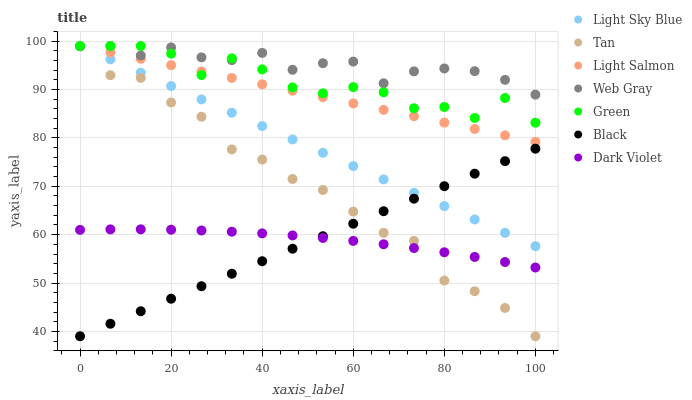Does Black have the minimum area under the curve?
Answer yes or no. Yes. Does Web Gray have the maximum area under the curve?
Answer yes or no. Yes. Does Dark Violet have the minimum area under the curve?
Answer yes or no. No. Does Dark Violet have the maximum area under the curve?
Answer yes or no. No. Is Black the smoothest?
Answer yes or no. Yes. Is Green the roughest?
Answer yes or no. Yes. Is Web Gray the smoothest?
Answer yes or no. No. Is Web Gray the roughest?
Answer yes or no. No. Does Black have the lowest value?
Answer yes or no. Yes. Does Dark Violet have the lowest value?
Answer yes or no. No. Does Tan have the highest value?
Answer yes or no. Yes. Does Dark Violet have the highest value?
Answer yes or no. No. Is Dark Violet less than Web Gray?
Answer yes or no. Yes. Is Green greater than Black?
Answer yes or no. Yes. Does Web Gray intersect Tan?
Answer yes or no. Yes. Is Web Gray less than Tan?
Answer yes or no. No. Is Web Gray greater than Tan?
Answer yes or no. No. Does Dark Violet intersect Web Gray?
Answer yes or no. No. 